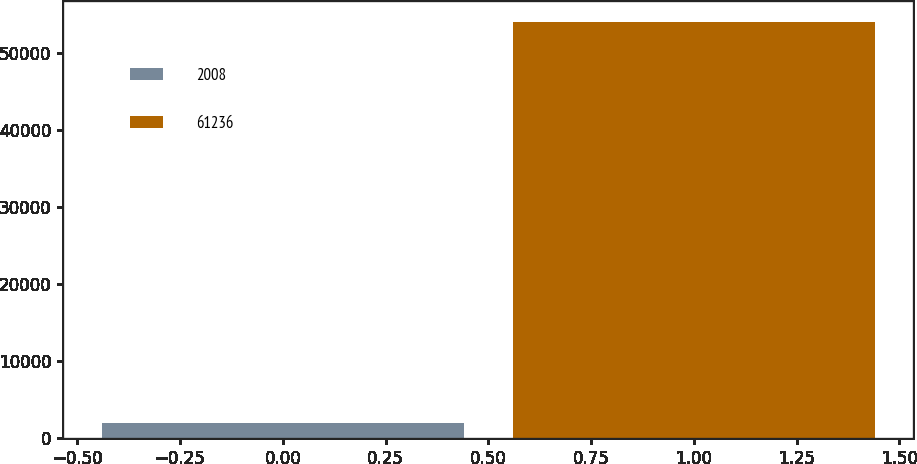<chart> <loc_0><loc_0><loc_500><loc_500><bar_chart><fcel>2008<fcel>61236<nl><fcel>2006<fcel>54041<nl></chart> 